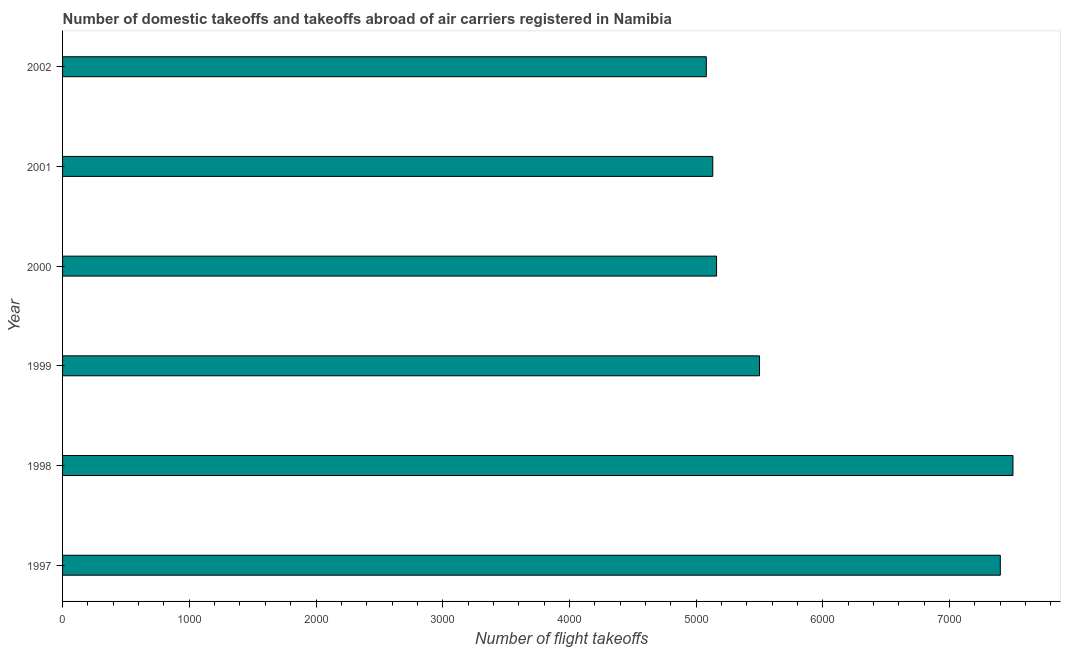What is the title of the graph?
Your answer should be very brief. Number of domestic takeoffs and takeoffs abroad of air carriers registered in Namibia. What is the label or title of the X-axis?
Make the answer very short. Number of flight takeoffs. What is the number of flight takeoffs in 2001?
Keep it short and to the point. 5131. Across all years, what is the maximum number of flight takeoffs?
Offer a terse response. 7500. Across all years, what is the minimum number of flight takeoffs?
Ensure brevity in your answer.  5080. In which year was the number of flight takeoffs maximum?
Provide a succinct answer. 1998. What is the sum of the number of flight takeoffs?
Your answer should be compact. 3.58e+04. What is the difference between the number of flight takeoffs in 1998 and 2002?
Ensure brevity in your answer.  2420. What is the average number of flight takeoffs per year?
Offer a terse response. 5962. What is the median number of flight takeoffs?
Keep it short and to the point. 5330.5. In how many years, is the number of flight takeoffs greater than 3600 ?
Your answer should be compact. 6. What is the ratio of the number of flight takeoffs in 1997 to that in 2000?
Your answer should be very brief. 1.43. Is the number of flight takeoffs in 2001 less than that in 2002?
Make the answer very short. No. Is the difference between the number of flight takeoffs in 1997 and 2000 greater than the difference between any two years?
Offer a terse response. No. What is the difference between the highest and the second highest number of flight takeoffs?
Offer a terse response. 100. What is the difference between the highest and the lowest number of flight takeoffs?
Offer a terse response. 2420. Are all the bars in the graph horizontal?
Offer a terse response. Yes. How many years are there in the graph?
Ensure brevity in your answer.  6. What is the difference between two consecutive major ticks on the X-axis?
Keep it short and to the point. 1000. What is the Number of flight takeoffs of 1997?
Offer a terse response. 7400. What is the Number of flight takeoffs of 1998?
Your answer should be compact. 7500. What is the Number of flight takeoffs in 1999?
Provide a short and direct response. 5500. What is the Number of flight takeoffs of 2000?
Offer a very short reply. 5161. What is the Number of flight takeoffs in 2001?
Offer a very short reply. 5131. What is the Number of flight takeoffs in 2002?
Ensure brevity in your answer.  5080. What is the difference between the Number of flight takeoffs in 1997 and 1998?
Make the answer very short. -100. What is the difference between the Number of flight takeoffs in 1997 and 1999?
Give a very brief answer. 1900. What is the difference between the Number of flight takeoffs in 1997 and 2000?
Keep it short and to the point. 2239. What is the difference between the Number of flight takeoffs in 1997 and 2001?
Your answer should be very brief. 2269. What is the difference between the Number of flight takeoffs in 1997 and 2002?
Keep it short and to the point. 2320. What is the difference between the Number of flight takeoffs in 1998 and 2000?
Provide a succinct answer. 2339. What is the difference between the Number of flight takeoffs in 1998 and 2001?
Ensure brevity in your answer.  2369. What is the difference between the Number of flight takeoffs in 1998 and 2002?
Ensure brevity in your answer.  2420. What is the difference between the Number of flight takeoffs in 1999 and 2000?
Your response must be concise. 339. What is the difference between the Number of flight takeoffs in 1999 and 2001?
Give a very brief answer. 369. What is the difference between the Number of flight takeoffs in 1999 and 2002?
Offer a terse response. 420. What is the difference between the Number of flight takeoffs in 2000 and 2001?
Offer a very short reply. 30. What is the difference between the Number of flight takeoffs in 2000 and 2002?
Provide a succinct answer. 81. What is the ratio of the Number of flight takeoffs in 1997 to that in 1998?
Provide a short and direct response. 0.99. What is the ratio of the Number of flight takeoffs in 1997 to that in 1999?
Ensure brevity in your answer.  1.34. What is the ratio of the Number of flight takeoffs in 1997 to that in 2000?
Give a very brief answer. 1.43. What is the ratio of the Number of flight takeoffs in 1997 to that in 2001?
Offer a very short reply. 1.44. What is the ratio of the Number of flight takeoffs in 1997 to that in 2002?
Provide a succinct answer. 1.46. What is the ratio of the Number of flight takeoffs in 1998 to that in 1999?
Give a very brief answer. 1.36. What is the ratio of the Number of flight takeoffs in 1998 to that in 2000?
Your answer should be compact. 1.45. What is the ratio of the Number of flight takeoffs in 1998 to that in 2001?
Give a very brief answer. 1.46. What is the ratio of the Number of flight takeoffs in 1998 to that in 2002?
Offer a very short reply. 1.48. What is the ratio of the Number of flight takeoffs in 1999 to that in 2000?
Your answer should be very brief. 1.07. What is the ratio of the Number of flight takeoffs in 1999 to that in 2001?
Your response must be concise. 1.07. What is the ratio of the Number of flight takeoffs in 1999 to that in 2002?
Give a very brief answer. 1.08. What is the ratio of the Number of flight takeoffs in 2000 to that in 2001?
Give a very brief answer. 1.01. 